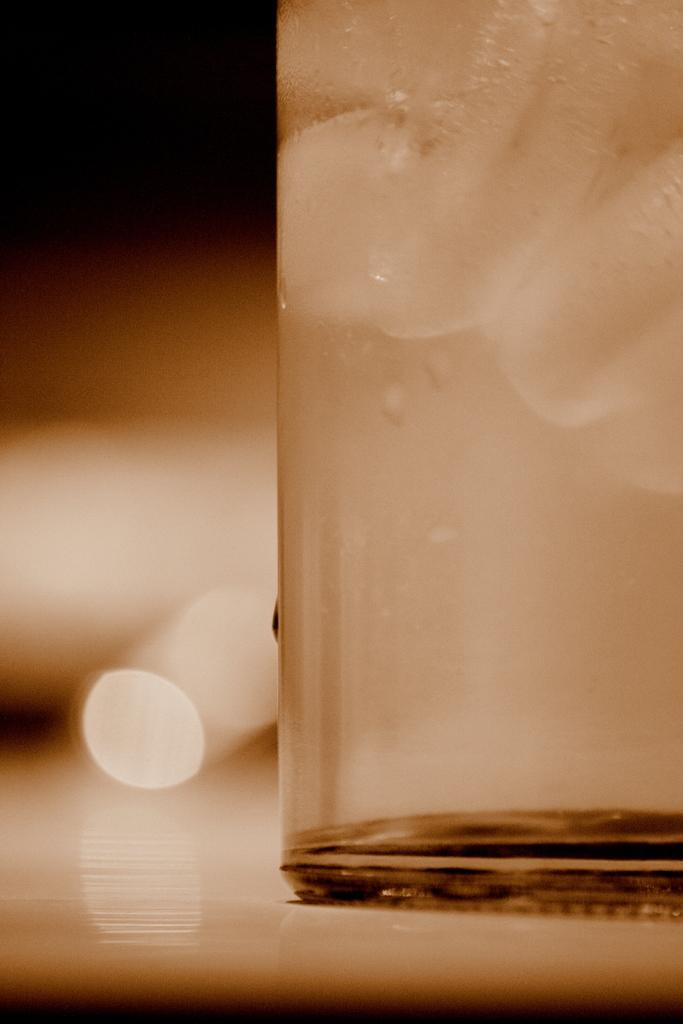What is located in the foreground of the image? There is a glass in the foreground of the image. On which side of the image is the glass placed? The glass is on the right side of the image. What can be observed on the surface of the glass? There are droplets of water on the glass. What is the color of the surface on which the glass is placed? The glass is placed on a white surface. How would you describe the background of the image? The background of the image is blurred. Can you see a knife being used by the grandfather in the basket in the image? There is no knife, grandfather, or basket present in the image. 